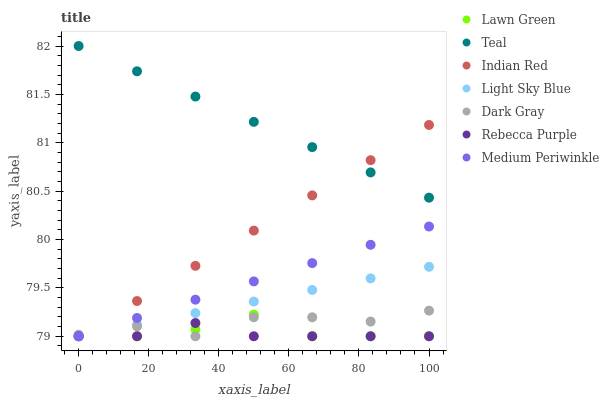Does Rebecca Purple have the minimum area under the curve?
Answer yes or no. Yes. Does Teal have the maximum area under the curve?
Answer yes or no. Yes. Does Medium Periwinkle have the minimum area under the curve?
Answer yes or no. No. Does Medium Periwinkle have the maximum area under the curve?
Answer yes or no. No. Is Medium Periwinkle the smoothest?
Answer yes or no. Yes. Is Dark Gray the roughest?
Answer yes or no. Yes. Is Teal the smoothest?
Answer yes or no. No. Is Teal the roughest?
Answer yes or no. No. Does Lawn Green have the lowest value?
Answer yes or no. Yes. Does Teal have the lowest value?
Answer yes or no. No. Does Teal have the highest value?
Answer yes or no. Yes. Does Medium Periwinkle have the highest value?
Answer yes or no. No. Is Lawn Green less than Teal?
Answer yes or no. Yes. Is Teal greater than Rebecca Purple?
Answer yes or no. Yes. Does Light Sky Blue intersect Dark Gray?
Answer yes or no. Yes. Is Light Sky Blue less than Dark Gray?
Answer yes or no. No. Is Light Sky Blue greater than Dark Gray?
Answer yes or no. No. Does Lawn Green intersect Teal?
Answer yes or no. No. 